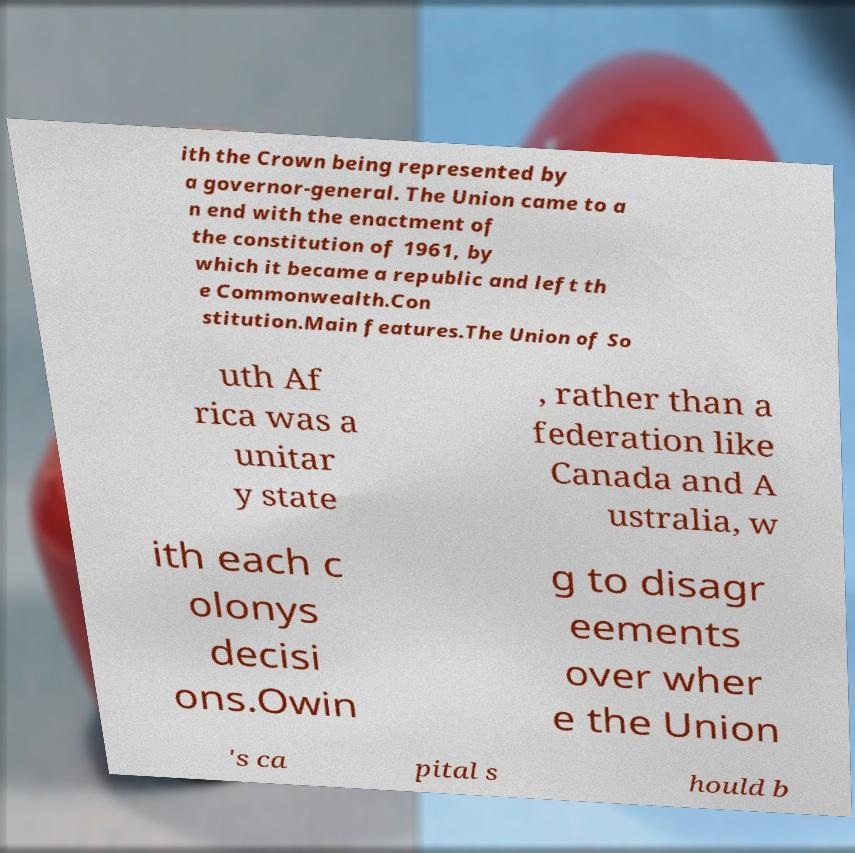I need the written content from this picture converted into text. Can you do that? ith the Crown being represented by a governor-general. The Union came to a n end with the enactment of the constitution of 1961, by which it became a republic and left th e Commonwealth.Con stitution.Main features.The Union of So uth Af rica was a unitar y state , rather than a federation like Canada and A ustralia, w ith each c olonys decisi ons.Owin g to disagr eements over wher e the Union 's ca pital s hould b 